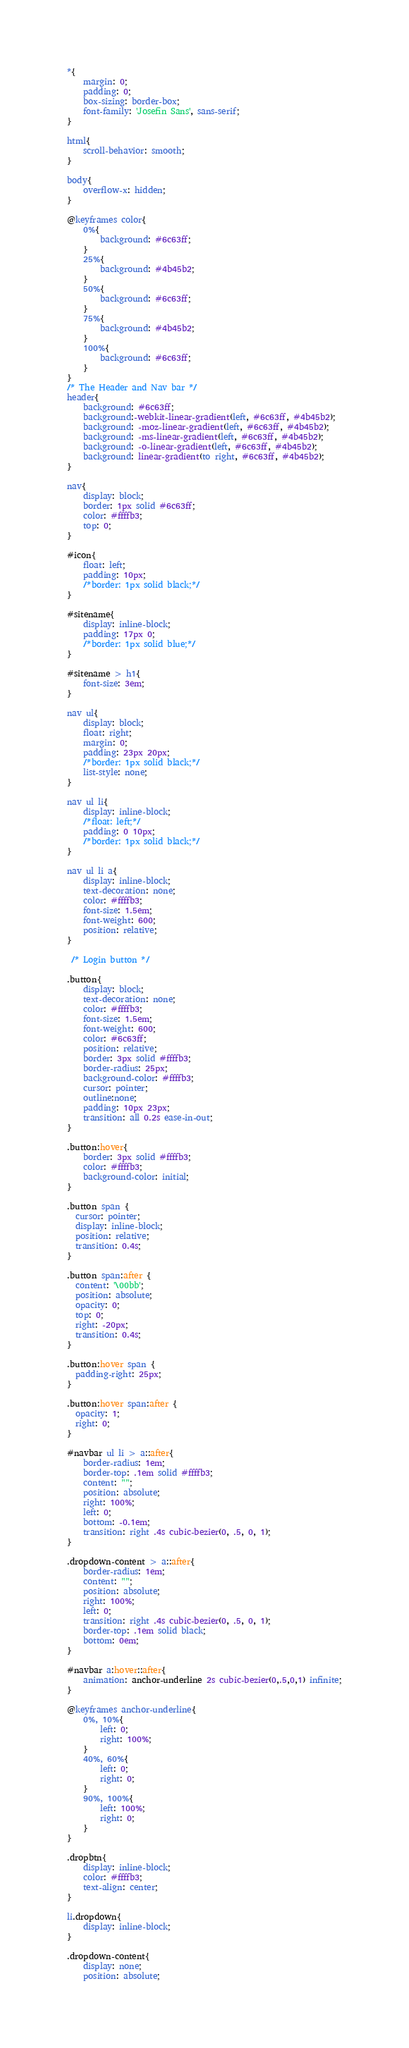Convert code to text. <code><loc_0><loc_0><loc_500><loc_500><_CSS_>*{
	margin: 0;
	padding: 0;
	box-sizing: border-box;
	font-family: 'Josefin Sans', sans-serif;
}

html{
	scroll-behavior: smooth;
}

body{
	overflow-x: hidden;
}

@keyframes color{
	0%{
		background: #6c63ff;
	}
	25%{
		background: #4b45b2;
	}
	50%{
		background: #6c63ff;
	}
	75%{
		background: #4b45b2;	
	}
	100%{
		background: #6c63ff;
	}
}
/* The Header and Nav bar */
header{
	background: #6c63ff;
	background:-webkit-linear-gradient(left, #6c63ff, #4b45b2);
	background: -moz-linear-gradient(left, #6c63ff, #4b45b2);
	background: -ms-linear-gradient(left, #6c63ff, #4b45b2);
	background: -o-linear-gradient(left, #6c63ff, #4b45b2);
	background: linear-gradient(to right, #6c63ff, #4b45b2);
}

nav{
	display: block;
	border: 1px solid #6c63ff;
	color: #ffffb3;
	top: 0;
}

#icon{
	float: left;
	padding: 10px;
	/*border: 1px solid black;*/
}

#sitename{
	display: inline-block;
	padding: 17px 0;
	/*border: 1px solid blue;*/
}

#sitename > h1{
	font-size: 3em;
}

nav ul{
	display: block;
	float: right;
	margin: 0;
	padding: 23px 20px;
	/*border: 1px solid black;*/
	list-style: none;
}

nav ul li{
	display: inline-block;
	/*float: left;*/
	padding: 0 10px;
	/*border: 1px solid black;*/
}

nav ul li a{
	display: inline-block;
	text-decoration: none;
	color: #ffffb3;
	font-size: 1.5em;
	font-weight: 600;
	position: relative;
}

 /* Login button */

.button{
	display: block;
	text-decoration: none;
	color: #ffffb3;
	font-size: 1.5em;
	font-weight: 600;
	color: #6c63ff;
	position: relative;	
	border: 3px solid #ffffb3;
	border-radius: 25px;
	background-color: #ffffb3;   
	cursor: pointer;
	outline:none;
	padding: 10px 23px;
	transition: all 0.2s ease-in-out;
}

.button:hover{
	border: 3px solid #ffffb3;
	color: #ffffb3;
	background-color: initial;
}

.button span {
  cursor: pointer;
  display: inline-block;
  position: relative;
  transition: 0.4s;
}

.button span:after {
  content: '\00bb';
  position: absolute;
  opacity: 0;
  top: 0;
  right: -20px;
  transition: 0.4s;
}

.button:hover span {
  padding-right: 25px;
}

.button:hover span:after {
  opacity: 1;
  right: 0;
}

#navbar ul li > a::after{
	border-radius: 1em;
	border-top: .1em solid #ffffb3;
	content: "";
	position: absolute;
	right: 100%;
	left: 0;
	bottom: -0.1em;
	transition: right .4s cubic-bezier(0, .5, 0, 1);
}

.dropdown-content > a::after{
	border-radius: 1em;
	content: "";
	position: absolute;
	right: 100%;
	left: 0;
	transition: right .4s cubic-bezier(0, .5, 0, 1);
	border-top: .1em solid black;
	bottom: 0em;
}

#navbar a:hover::after{
	animation: anchor-underline 2s cubic-bezier(0,.5,0,1) infinite;
}

@keyframes anchor-underline{
	0%, 10%{
		left: 0;
		right: 100%;
	}
	40%, 60%{
		left: 0;
		right: 0;
	}
	90%, 100%{
		left: 100%;
		right: 0;
	}
}

.dropbtn{
	display: inline-block;
	color: #ffffb3;
	text-align: center;
}

li.dropdown{
	display: inline-block;
}

.dropdown-content{
	display: none;
	position: absolute;</code> 